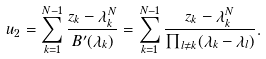Convert formula to latex. <formula><loc_0><loc_0><loc_500><loc_500>u _ { 2 } = \sum _ { k = 1 } ^ { N - 1 } \frac { z _ { k } - \lambda _ { k } ^ { N } } { B ^ { \prime } ( \lambda _ { k } ) } = \sum _ { k = 1 } ^ { N - 1 } \frac { z _ { k } - \lambda _ { k } ^ { N } } { \prod _ { l \neq k } ( \lambda _ { k } - \lambda _ { l } ) } .</formula> 